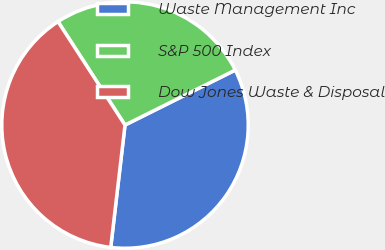Convert chart to OTSL. <chart><loc_0><loc_0><loc_500><loc_500><pie_chart><fcel>Waste Management Inc<fcel>S&P 500 Index<fcel>Dow Jones Waste & Disposal<nl><fcel>34.21%<fcel>26.79%<fcel>39.0%<nl></chart> 